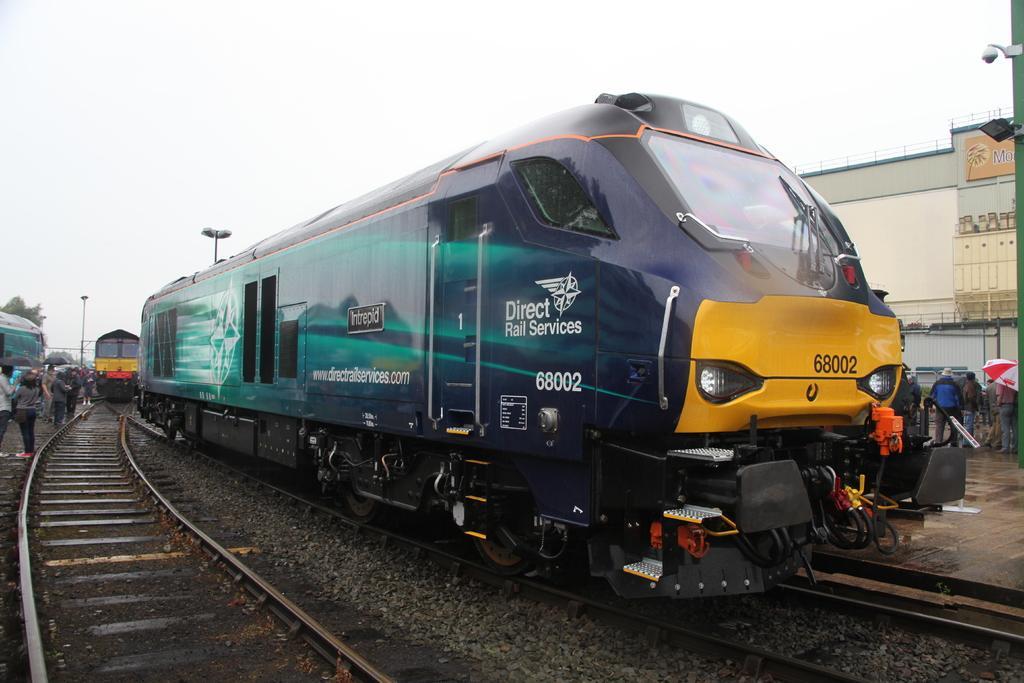Could you give a brief overview of what you see in this image? In this image we can see a few people, some of them are holding umbrellas, there are trains on the tracks, we can see some text on a train, there are poles, light poles, a CCTV camera, there is a building, trees, also we can see the sky. 